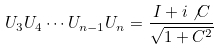<formula> <loc_0><loc_0><loc_500><loc_500>U _ { 3 } U _ { 4 } \cdots U _ { n - 1 } U _ { n } = \frac { I + i \not C } { \sqrt { 1 + C ^ { 2 } } }</formula> 